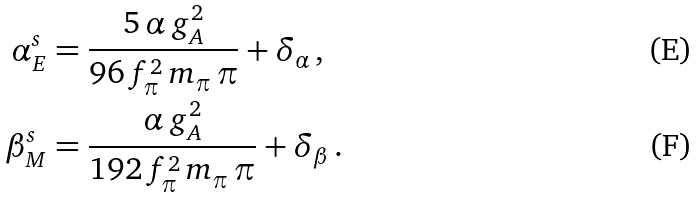<formula> <loc_0><loc_0><loc_500><loc_500>\alpha _ { E } ^ { s } & = \frac { 5 \, \alpha \, g _ { A } ^ { 2 } } { 9 6 \, f _ { \pi } ^ { 2 } \, m _ { \pi } \, \pi } + \delta _ { \alpha } \, , \\ \beta _ { M } ^ { s } & = \frac { \alpha \, g _ { A } ^ { 2 } } { 1 9 2 \, f _ { \pi } ^ { 2 } \, m _ { \pi } \, \pi } + \delta _ { \beta } \, .</formula> 